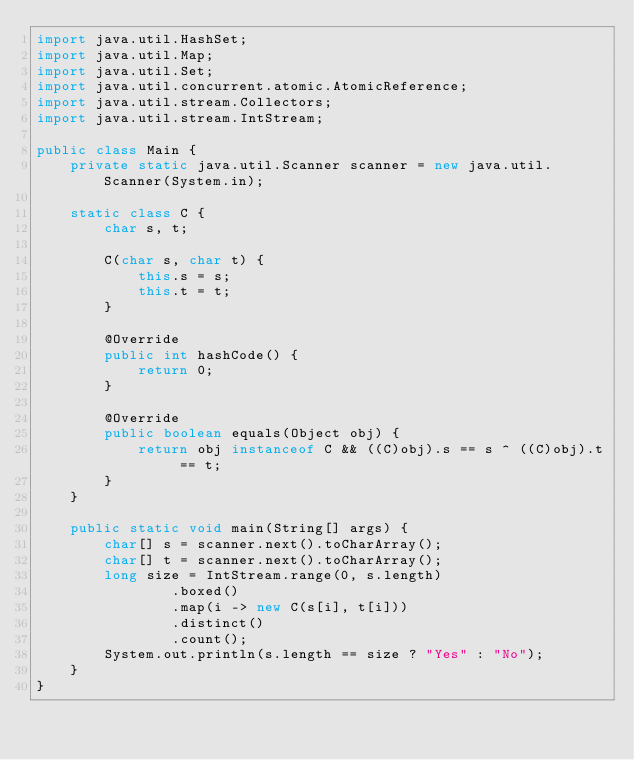<code> <loc_0><loc_0><loc_500><loc_500><_Java_>import java.util.HashSet;
import java.util.Map;
import java.util.Set;
import java.util.concurrent.atomic.AtomicReference;
import java.util.stream.Collectors;
import java.util.stream.IntStream;

public class Main {
    private static java.util.Scanner scanner = new java.util.Scanner(System.in);

    static class C {
        char s, t;

        C(char s, char t) {
            this.s = s;
            this.t = t;
        }

        @Override
        public int hashCode() {
            return 0;
        }

        @Override
        public boolean equals(Object obj) {
            return obj instanceof C && ((C)obj).s == s ^ ((C)obj).t == t;
        }
    }

    public static void main(String[] args) {
        char[] s = scanner.next().toCharArray();
        char[] t = scanner.next().toCharArray();
        long size = IntStream.range(0, s.length)
                .boxed()
                .map(i -> new C(s[i], t[i]))
                .distinct()
                .count();
        System.out.println(s.length == size ? "Yes" : "No");
    }
}</code> 